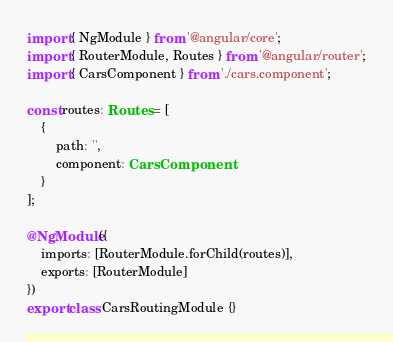<code> <loc_0><loc_0><loc_500><loc_500><_TypeScript_>import { NgModule } from '@angular/core';
import { RouterModule, Routes } from '@angular/router';
import { CarsComponent } from './cars.component';

const routes: Routes = [
    {
        path: '',
        component: CarsComponent
    }
];

@NgModule({
    imports: [RouterModule.forChild(routes)],
    exports: [RouterModule]
})
export class CarsRoutingModule {}
</code> 